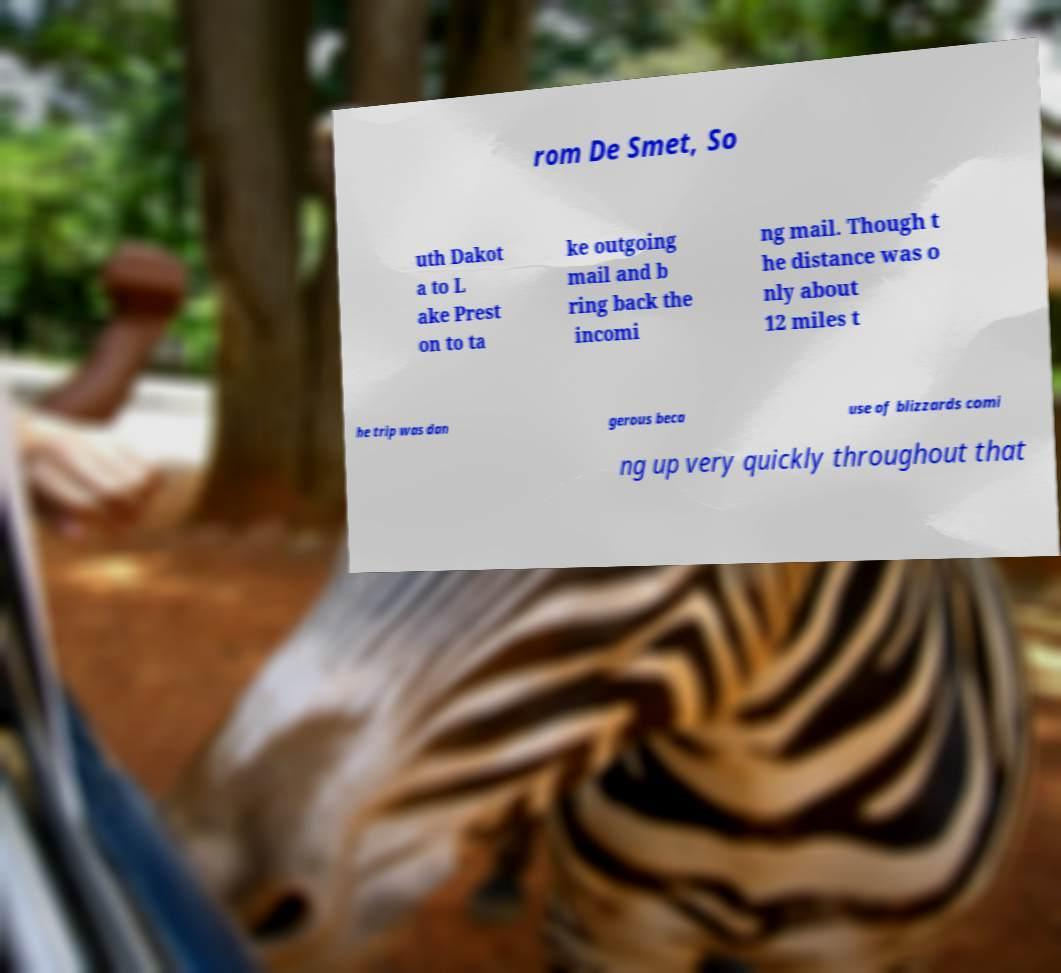What messages or text are displayed in this image? I need them in a readable, typed format. rom De Smet, So uth Dakot a to L ake Prest on to ta ke outgoing mail and b ring back the incomi ng mail. Though t he distance was o nly about 12 miles t he trip was dan gerous beca use of blizzards comi ng up very quickly throughout that 